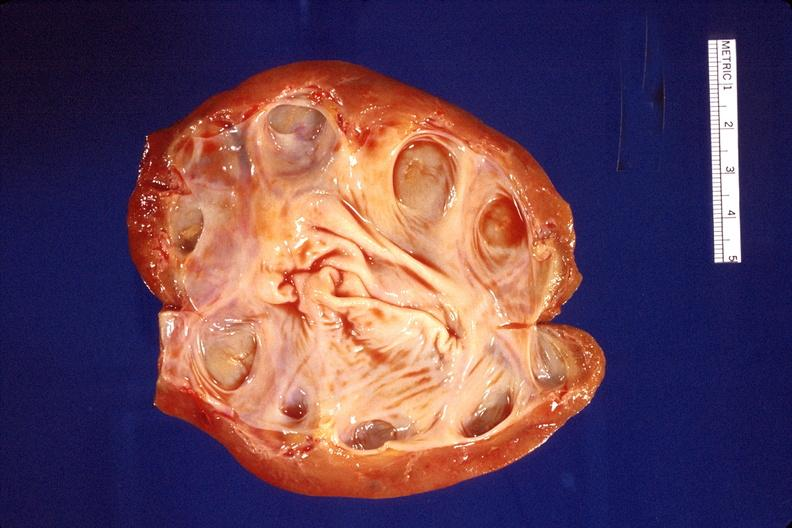does this image show kidney, hydronephrosis?
Answer the question using a single word or phrase. Yes 